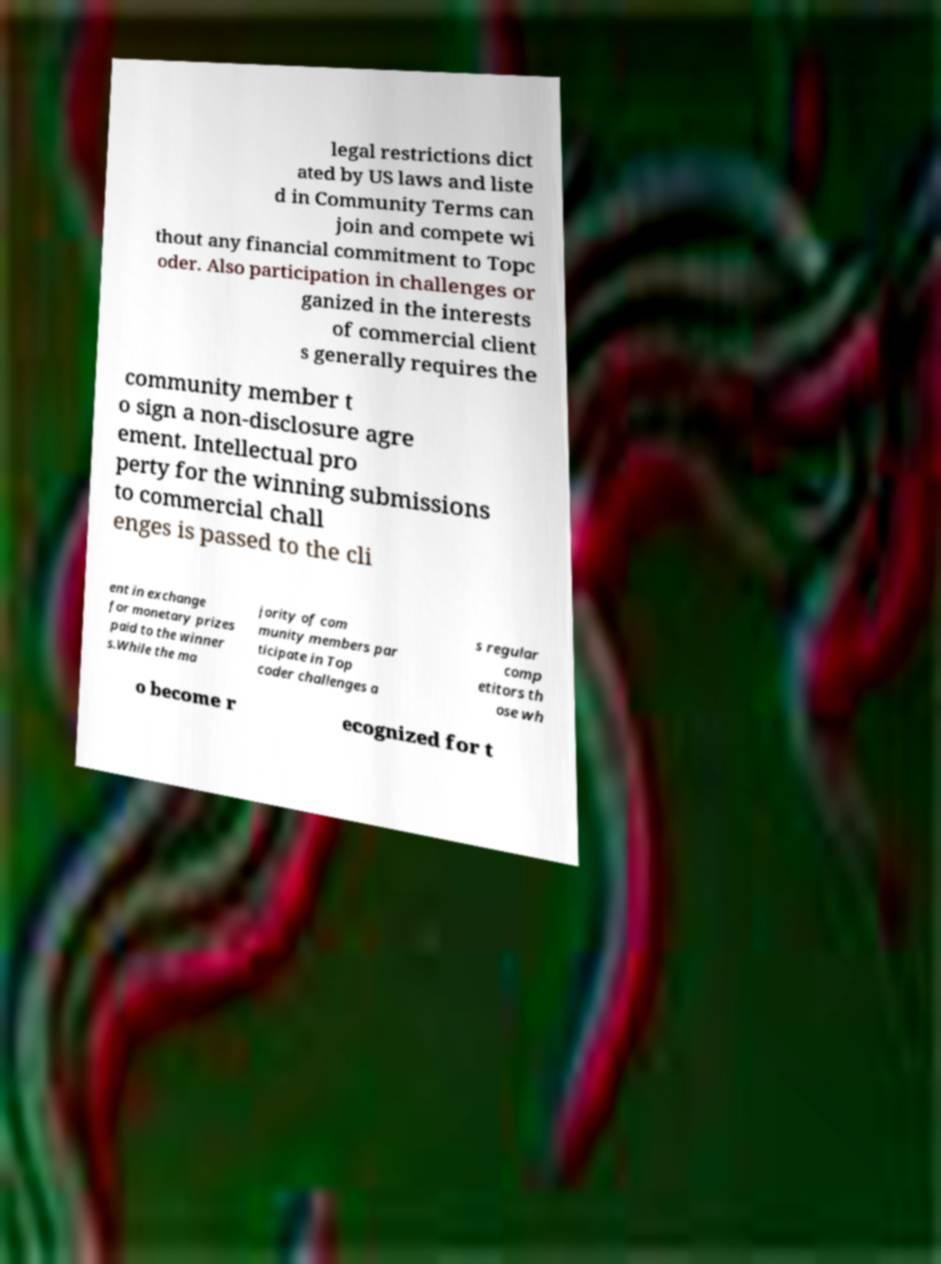Can you read and provide the text displayed in the image?This photo seems to have some interesting text. Can you extract and type it out for me? legal restrictions dict ated by US laws and liste d in Community Terms can join and compete wi thout any financial commitment to Topc oder. Also participation in challenges or ganized in the interests of commercial client s generally requires the community member t o sign a non-disclosure agre ement. Intellectual pro perty for the winning submissions to commercial chall enges is passed to the cli ent in exchange for monetary prizes paid to the winner s.While the ma jority of com munity members par ticipate in Top coder challenges a s regular comp etitors th ose wh o become r ecognized for t 